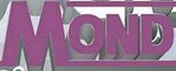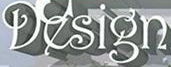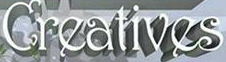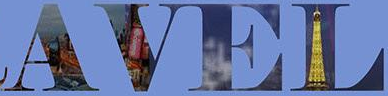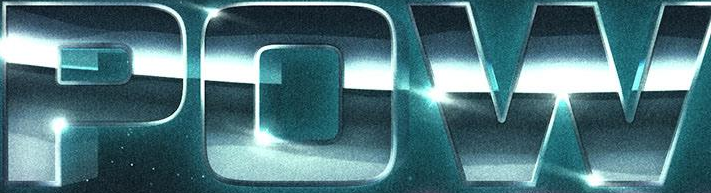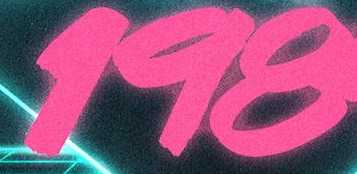Read the text content from these images in order, separated by a semicolon. MOND; Design; Creatives; AVEL; POW; 198 